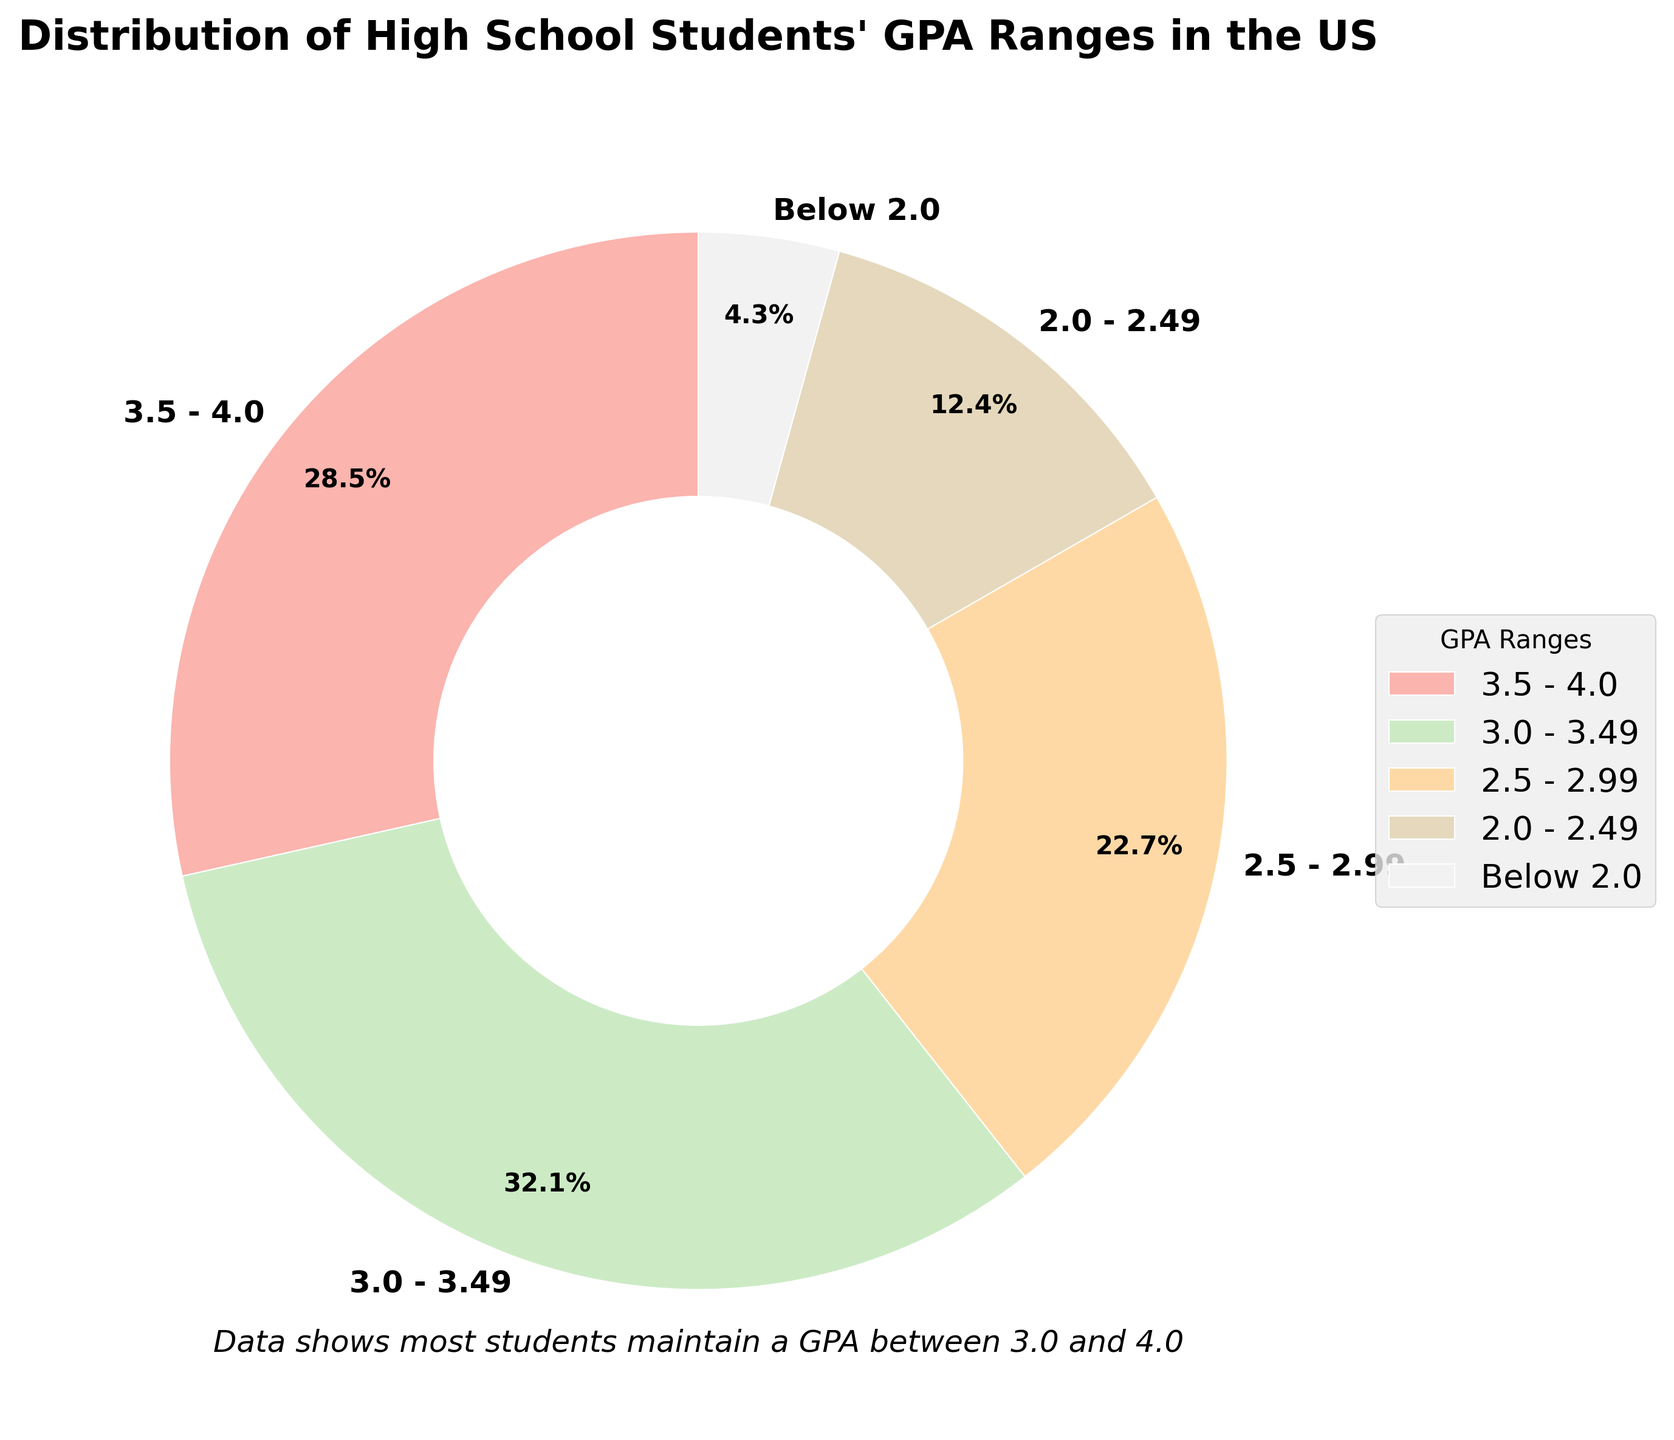What's the most common GPA range among high school students in the US? By looking at the pie chart, the largest wedge represents the most common GPA range. The slice labeled "3.0 - 3.49" occupies the largest portion of the pie chart, indicating it's the most common range.
Answer: 3.0 - 3.49 Which GPA range is the least common among high school students in the US? By observing the pie chart, the smallest wedge represents the least common GPA range. The slice labeled "Below 2.0" is the smallest, indicating it is the least common range.
Answer: Below 2.0 What percentage of students have a GPA of 3.5 or higher? To find this, sum the percentages of the GPA ranges "3.5 - 4.0". The slice labeled "3.5 - 4.0" shows 28.5%, so the percentage of students with a GPA of 3.5 or higher is 28.5%.
Answer: 28.5% What is the combined percentage of students who have a GPA below 3.0? Sum the percentages of the GPA ranges "2.5 - 2.99", "2.0 - 2.49", and "Below 2.0". The percentages are 22.7%, 12.4%, and 4.3%, respectively. Adding them gives 22.7 + 12.4 + 4.3 = 39.4%.
Answer: 39.4% Is the percentage of students with a GPA between 3.0 and 3.49 greater than those with a GPA between 2.5 and 2.99? Compare the percentages: 32.1% for "3.0 - 3.49" and 22.7% for "2.5 - 2.99". Since 32.1% is greater than 22.7%, the percentage for the 3.0 - 3.49 range is greater.
Answer: Yes Which GPA range's wedge is depicted in the color closest to light pink? The color closest to light pink in the pie chart is part of a specific range. From the visual representation, the wedge labeled "3.0 - 3.49" is depicted in a color closest to light pink.
Answer: 3.0 - 3.49 If you combine the percentages for the GPA ranges 3.5 - 4.0 and 3.0 - 3.49, what is the total percentage? Sum the percentages for the ranges "3.5 - 4.0" and "3.0 - 3.49". The values are 28.5% and 32.1%, respectively. Adding them gives 28.5 + 32.1 = 60.6%.
Answer: 60.6% How does the percentage of students with a GPA between 2.0 and 2.49 compare to those with a GPA between 2.5 and 2.99? Compare the percentages of "2.0 - 2.49" and "2.5 - 2.99". The values are 12.4% and 22.7%, respectively. Since 12.4% is less than 22.7%, the percentage for the 2.0 - 2.49 range is smaller.
Answer: Smaller 